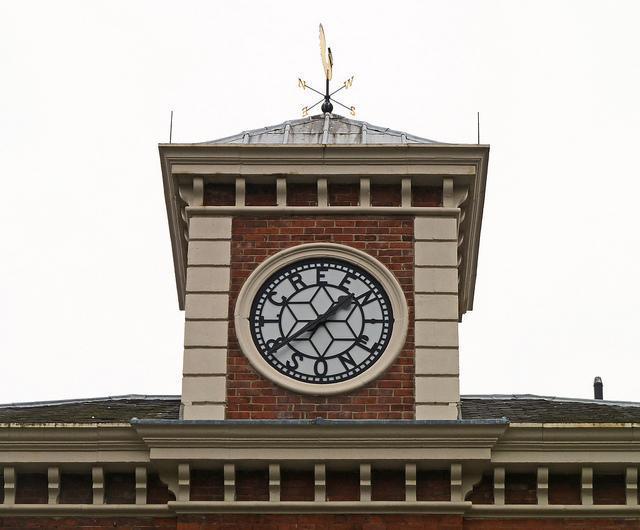How many people are sitting on the ledge?
Give a very brief answer. 0. 